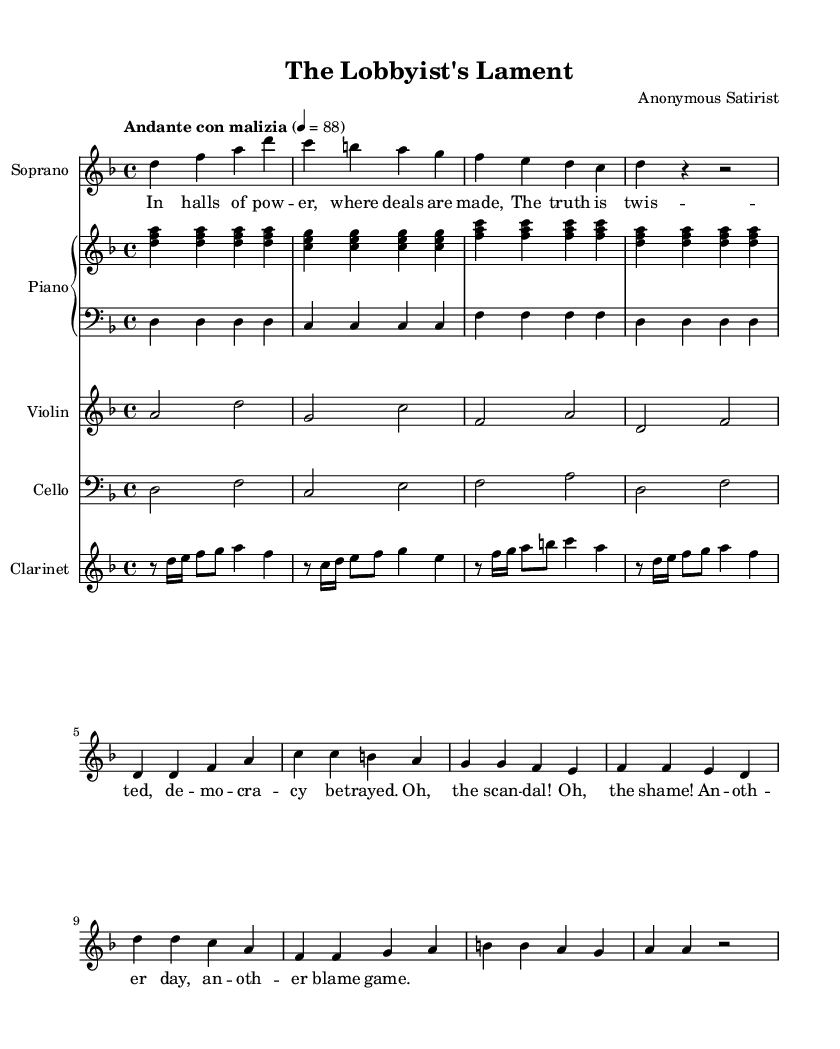what is the key signature of this music? The key signature is D minor, which has one flat (B flat). This is indicated at the beginning of the staff where the key signature symbols are placed.
Answer: D minor what is the time signature of this piece? The time signature is 4/4, as indicated at the beginning of the score. It tells us that there are four beats per measure, and the quarter note receives one beat.
Answer: 4/4 what is the tempo marking for this opera segment? The tempo marking is "Andante con malizia," which suggests a moderately slow tempo with a mischievous character. This is specified at the beginning of the score.
Answer: Andante con malizia how many measures are in the soprano part? The soprano part has eight measures, which can be counted by the number of vertical lines (barlines) separating the music into groups.
Answer: 8 which instruments are featured in the score? The instruments featured are Soprano, Piano (upper and lower), Violin, Cello, and Clarinet. Each of these instruments is listed at the beginning of their respective staves.
Answer: Soprano, Piano, Violin, Cello, Clarinet what is the thematic focus of the lyrics in this opera? The thematic focus of the lyrics revolves around the topics of power, scandal, and the betrayal of democracy, as articulated in the words provided under the soprano part.
Answer: Power and scandal what type of opera does this music represent? This music represents a satirical opera, characterized by its humorous and critical treatment of political and social issues, as indicated by the title and the content of the lyrics.
Answer: Satirical opera 